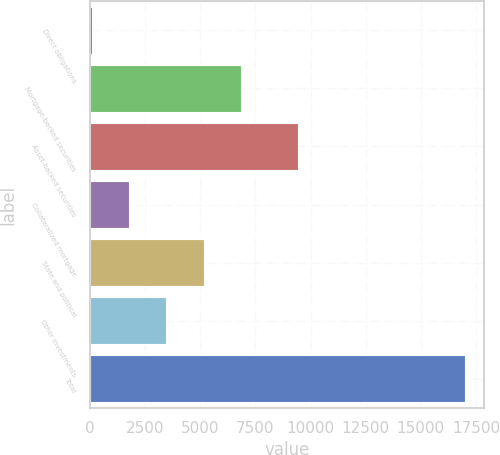Convert chart to OTSL. <chart><loc_0><loc_0><loc_500><loc_500><bar_chart><fcel>Direct obligations<fcel>Mortgage-backed securities<fcel>Asset-backed securities<fcel>Collateralized mortgage<fcel>State and political<fcel>Other investments<fcel>Total<nl><fcel>88<fcel>6854.8<fcel>9449<fcel>1779.7<fcel>5163.1<fcel>3471.4<fcel>17005<nl></chart> 